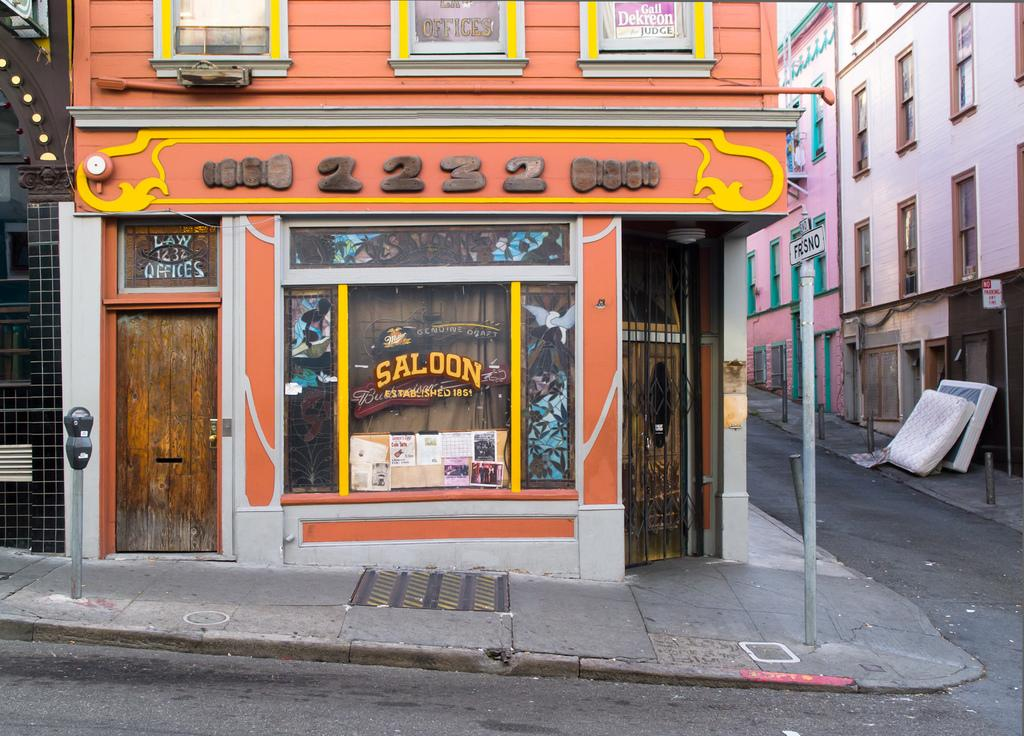What is the main subject in the center of the image? There is a building in the center of the image. What can be seen on the right side of the image? There are buildings on the right side of the image. What is present on the left side of the image? There are buildings on the left side of the image. What type of transportation infrastructure is visible in the image? There is a road visible in the image. What is located at the bottom of the image? There is a footpath at the bottom of the image. What type of berry is growing on the roof of the building in the image? There are no berries visible on the roof of the building in the image. 